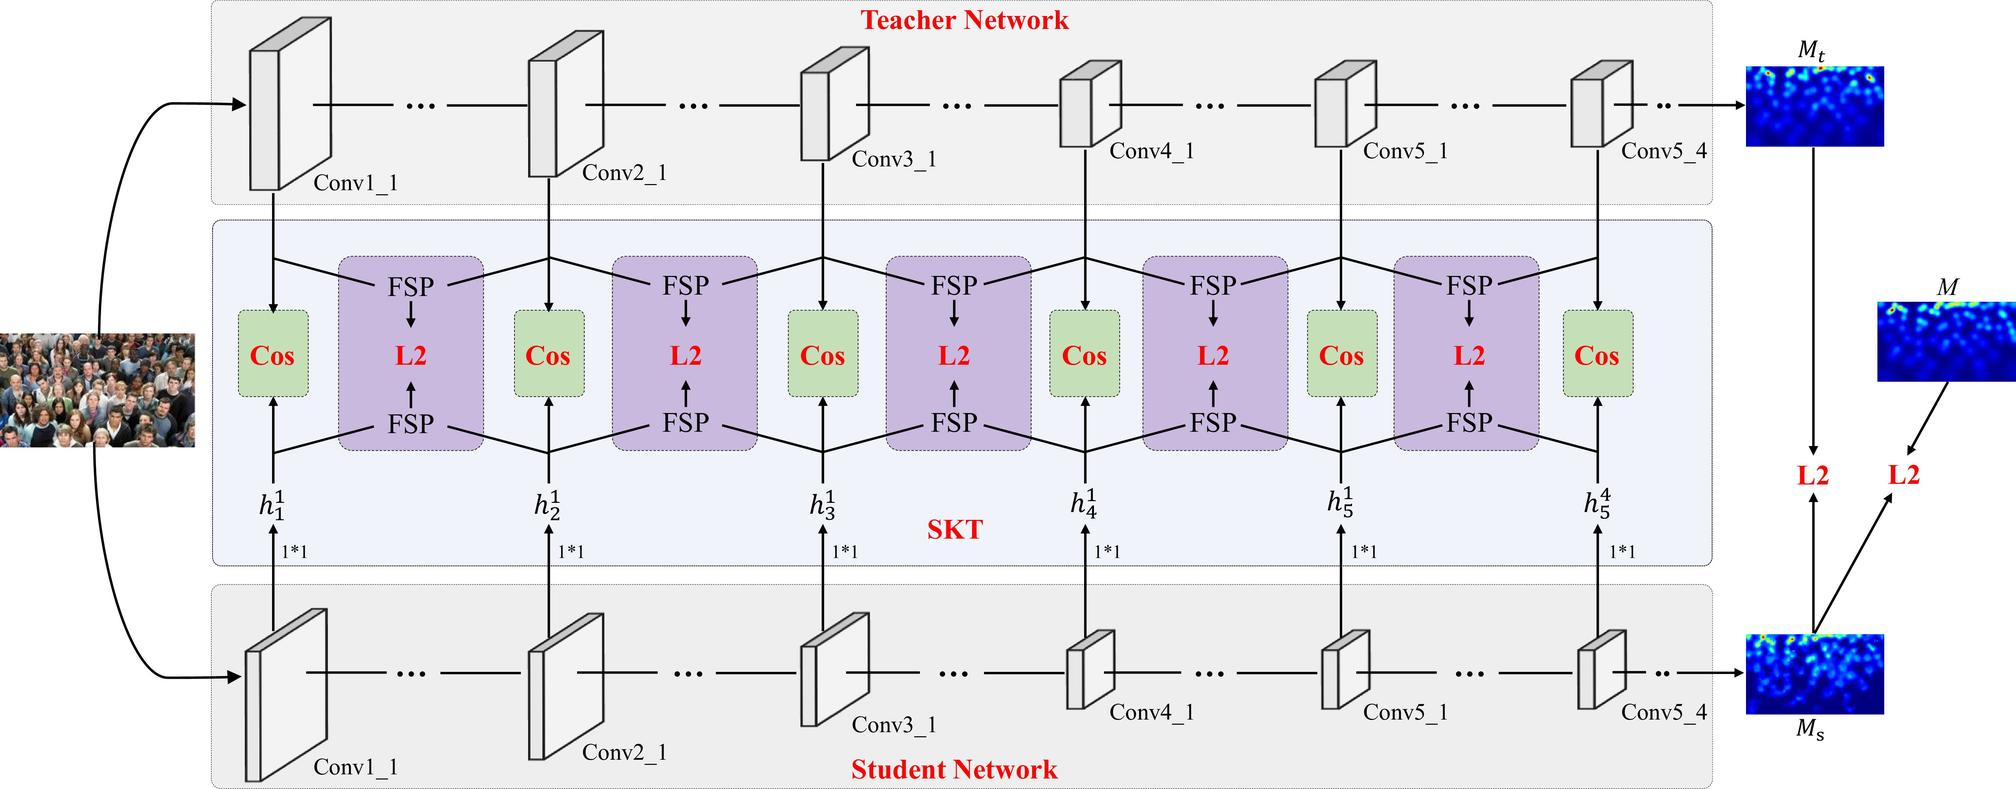In the diagram, what does 'FSP' stand for? A. Full Spectrum Processing B. Feature Space Preservation C. Feature Similarity Profile D. Focused Signal Processing In the context of the provided diagram, which illustrates a teacher-student network used in machine learning, 'FSP' most plausibly stands for 'Feature Similarity Profile'. This term refers to a measure or method in which the similarity between feature maps (the layers within a neural network that capture patterns or features from the input data) of a student network and a teacher network are compared. The FSP technique ensures that the student network, which is often smaller or less complex, learns representations that are similar to those of the larger, pre-trained teacher network. By comparing the feature maps at different layers in the networks, it helps in the knowledge distillation process, where the goal is to transfer knowledge from the teacher network to the student network in an efficient manner. Therefore, the most fitting answer from the provided options is 'C. Feature Similarity Profile'. It is important to note that without explicit confirmation, this interpretation is based on the common practices within the domain of neural network training and the visual information in the diagram. 